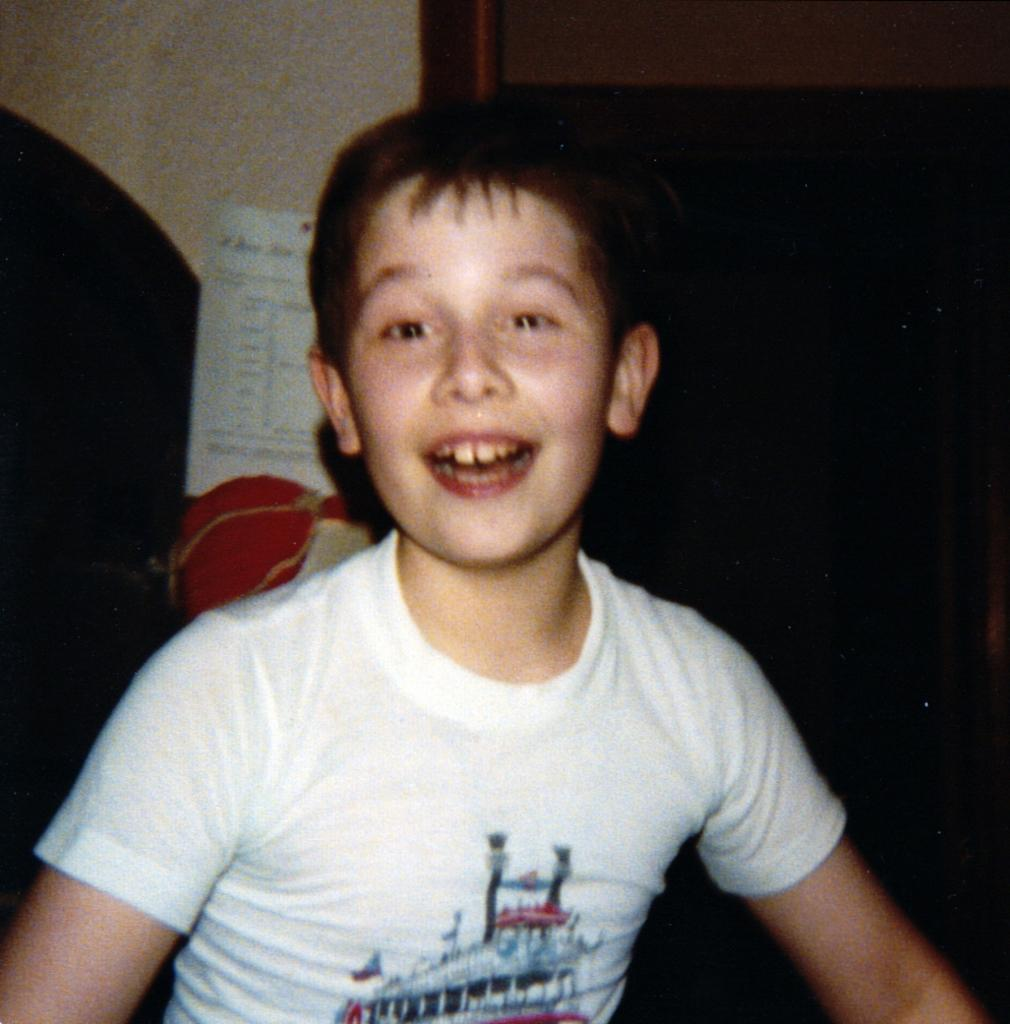Who is present in the image? There is a boy in the image. What is the boy's expression? The boy is smiling. What can be seen in the background of the image? There is a paper visible in the background of the image. How many letters are being written by the writer in the image? There is no writer or letters present in the image; it only features a boy smiling. 